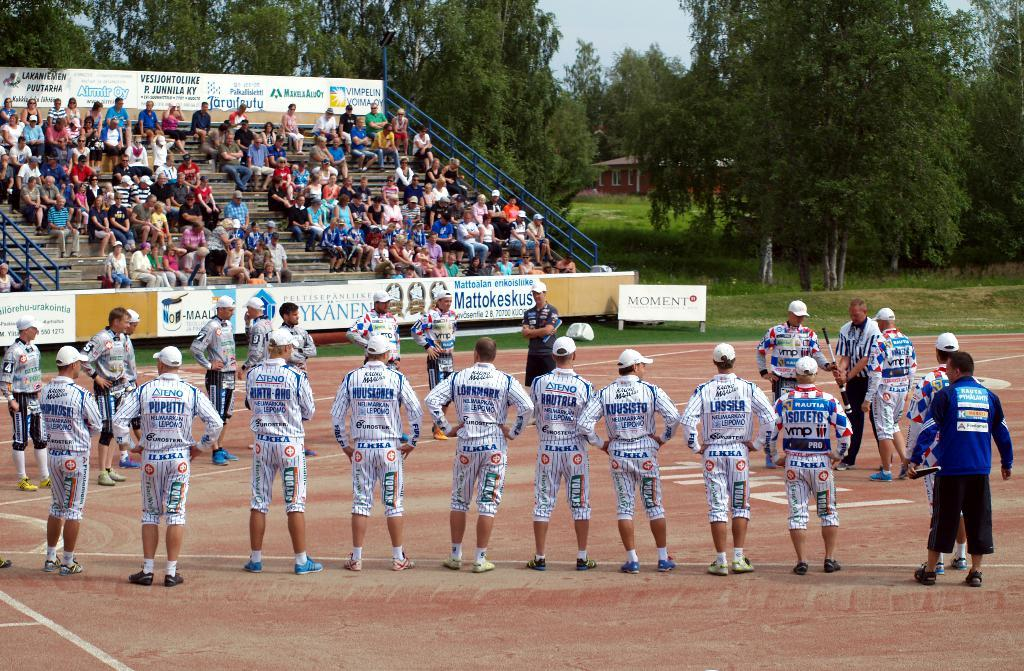<image>
Describe the image concisely. A group of players in ILKKA uniforms stand around field. 